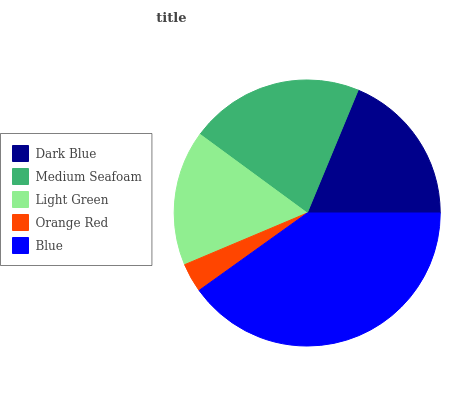Is Orange Red the minimum?
Answer yes or no. Yes. Is Blue the maximum?
Answer yes or no. Yes. Is Medium Seafoam the minimum?
Answer yes or no. No. Is Medium Seafoam the maximum?
Answer yes or no. No. Is Medium Seafoam greater than Dark Blue?
Answer yes or no. Yes. Is Dark Blue less than Medium Seafoam?
Answer yes or no. Yes. Is Dark Blue greater than Medium Seafoam?
Answer yes or no. No. Is Medium Seafoam less than Dark Blue?
Answer yes or no. No. Is Dark Blue the high median?
Answer yes or no. Yes. Is Dark Blue the low median?
Answer yes or no. Yes. Is Orange Red the high median?
Answer yes or no. No. Is Blue the low median?
Answer yes or no. No. 